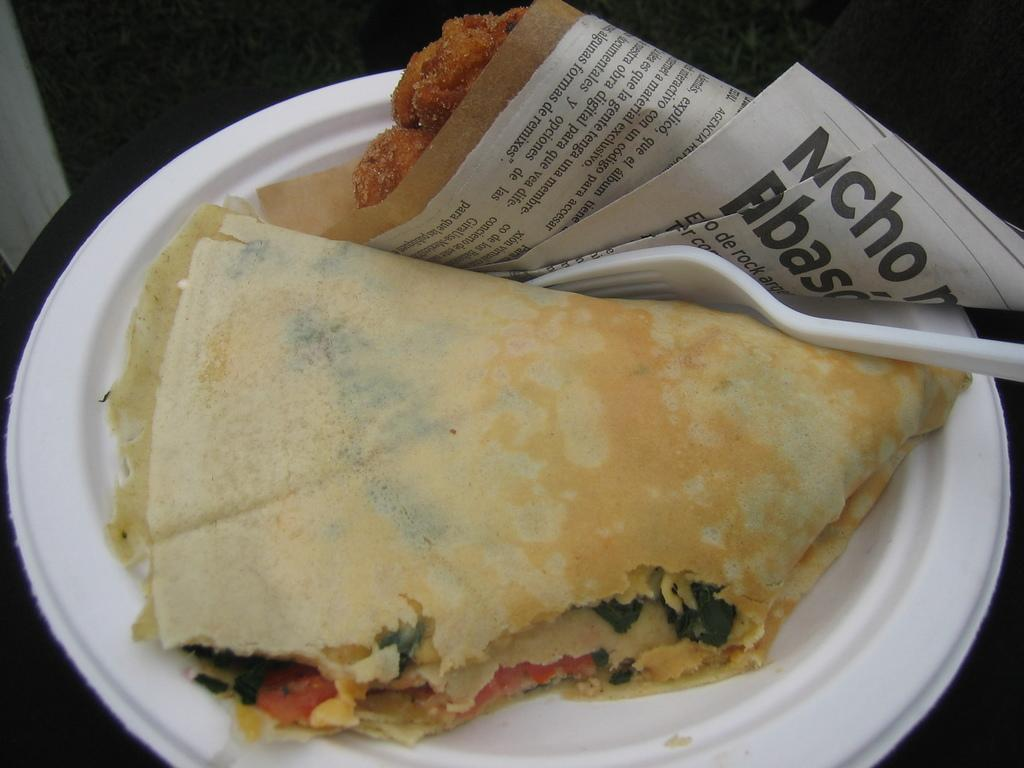What types of items can be seen in the image? There are food items and papers in the image. Can you describe the utensil and plate in the image? There is a fork on a white plate in the image. What is the color of the background in the image? The background of the image is dark. Can you tell me how many snails are crawling on the food items in the image? There are no snails present in the image; it only features food items and papers. What type of cloud can be seen in the image? There is no cloud visible in the image, as the background is dark. 